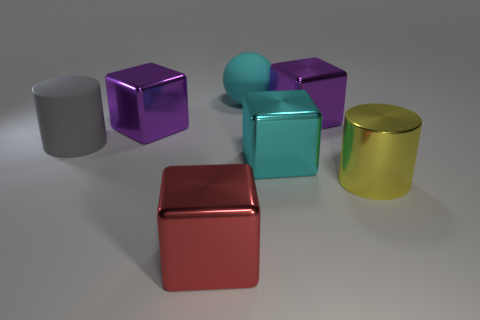Can you describe the lighting and shadows in the scene? The scene is softly lit from the upper left, casting gentle shadows to the right of the objects. This diffuse light creates a serene atmosphere and highlights the glossy texture of the objects. What does the arrangement of these objects suggest about the setting? The arrangement appears intentional, with ample space around each object, which might suggest this is a display set up to showcase the objects' colors and materials, perhaps for an advertisement or an artistic composition. 